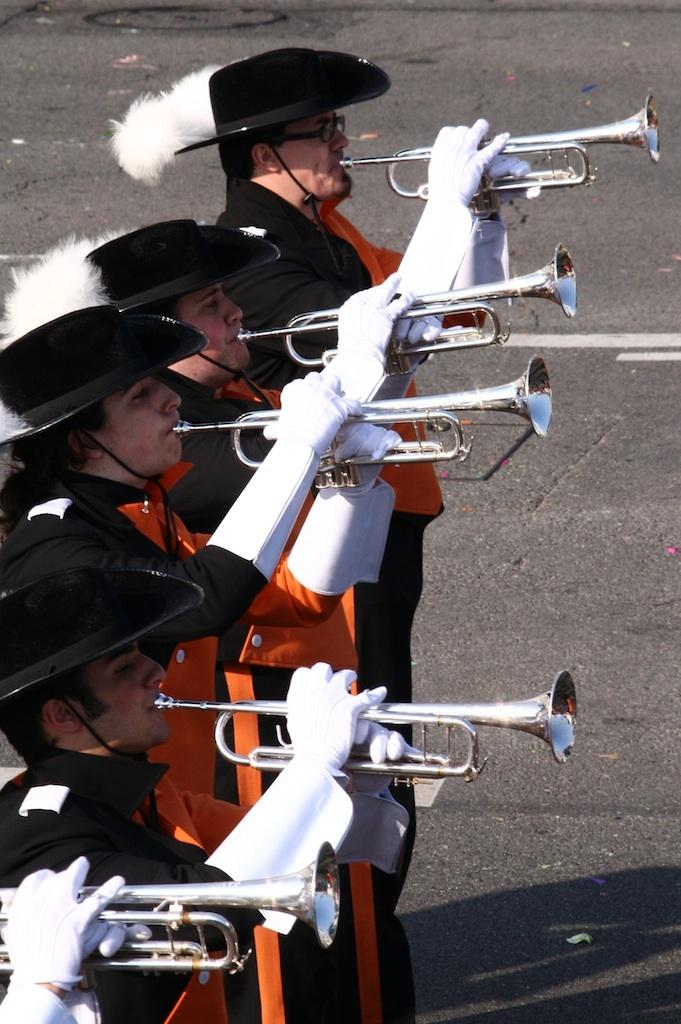How many people are in the image? There are people in the image, but the exact number is not specified. What are the people doing in the image? The people are standing and holding musical instruments. What colors are the people wearing in the image? The people are wearing black and orange color dresses. What accessory are the people wearing on their hands? The people are wearing white gloves. What type of wax can be seen melting in the image? There is no wax present in the image. What border is visible around the people in the image? There is no border visible around the people in the image. 